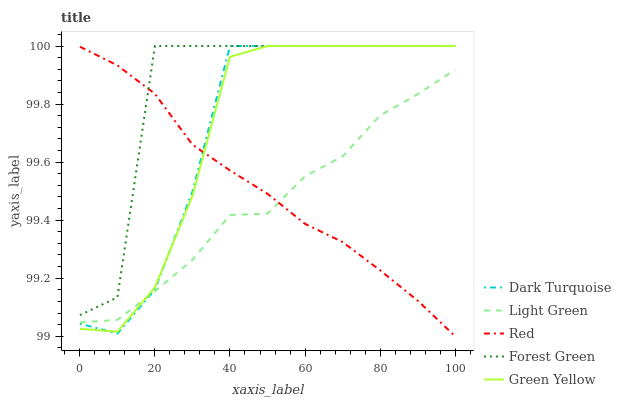Does Light Green have the minimum area under the curve?
Answer yes or no. Yes. Does Forest Green have the maximum area under the curve?
Answer yes or no. Yes. Does Green Yellow have the minimum area under the curve?
Answer yes or no. No. Does Green Yellow have the maximum area under the curve?
Answer yes or no. No. Is Red the smoothest?
Answer yes or no. Yes. Is Forest Green the roughest?
Answer yes or no. Yes. Is Green Yellow the smoothest?
Answer yes or no. No. Is Green Yellow the roughest?
Answer yes or no. No. Does Red have the lowest value?
Answer yes or no. Yes. Does Green Yellow have the lowest value?
Answer yes or no. No. Does Green Yellow have the highest value?
Answer yes or no. Yes. Does Red have the highest value?
Answer yes or no. No. Is Light Green less than Forest Green?
Answer yes or no. Yes. Is Forest Green greater than Light Green?
Answer yes or no. Yes. Does Forest Green intersect Red?
Answer yes or no. Yes. Is Forest Green less than Red?
Answer yes or no. No. Is Forest Green greater than Red?
Answer yes or no. No. Does Light Green intersect Forest Green?
Answer yes or no. No. 